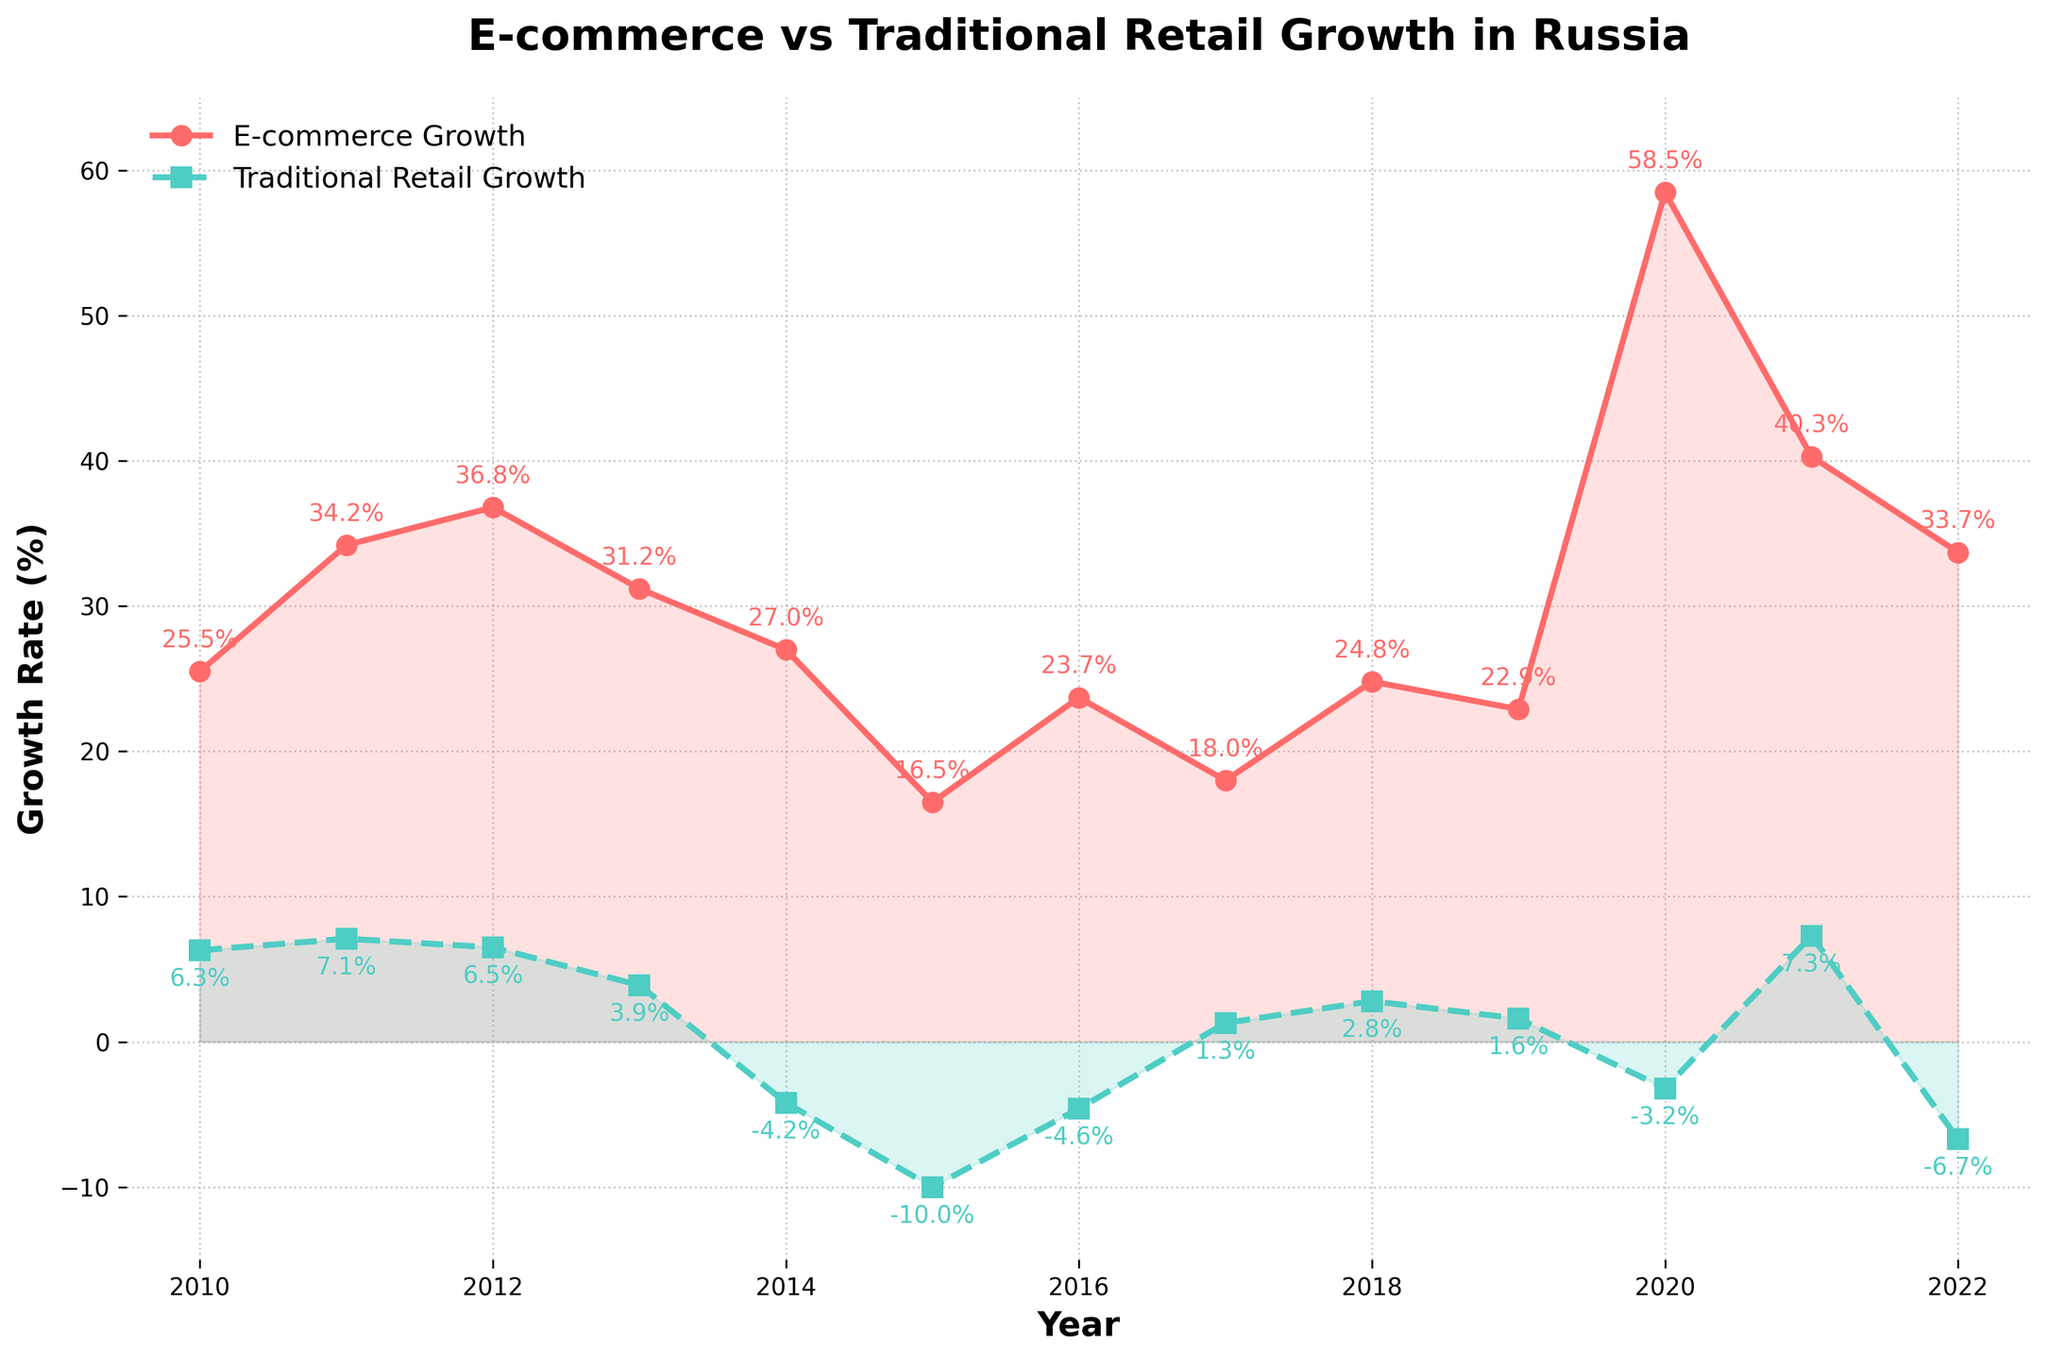What's the year with the highest growth in e-commerce? Identify the peak point in the line representing e-commerce growth. The highest point (58.5%) occurs in 2020.
Answer: 2020 Which year has the biggest difference between e-commerce and traditional retail growth rates? Calculate the difference between e-commerce and traditional retail growth for each year. The year with the largest gap is 2020 with a difference of 61.7% (58.5% - (-3.2%)).
Answer: 2020 During which years did e-commerce growth exceed 30%? Look at the points on the e-commerce line that are above the 30% mark. The years where e-commerce growth exceeded 30% are 2011, 2012, 2013, 2014, 2020, 2021, and 2022.
Answer: 2011, 2012, 2013, 2014, 2020, 2021, 2022 How many years did traditional retail experience negative growth? Count the years where the traditional retail line is below 0 on the y-axis. Negative growth years for traditional retail are 2014, 2015, 2016, 2020, and 2022.
Answer: 5 years In which year did e-commerce growth see the largest increase compared to the previous year? Subtract the e-commerce growth values of each year from its previous year to find the largest increase. The largest increase is between 2019 and 2020 (58.5% - 22.9% = 35.6%).
Answer: 2020 When was the traditional retail growth rate the lowest? Identify the lowest point on the traditional retail line. The lowest growth rate for traditional retail is -10.0% in 2015.
Answer: 2015 Which year had both e-commerce and traditional retail growth rates positive? Check for overlapping years where both lines are above the 0% mark. Only in 2011, 2012, 2013, 2017, 2018, and 2021 both e-commerce and traditional retail growth rates are positive.
Answer: 2011, 2012, 2013, 2017, 2018, 2021 What's the average growth rate of traditional retail over the years 2010-2022? Sum the traditional retail growth rates for each year, then divide by the number of years (13). (-33.3 / 13 = -2.56%).
Answer: -2.56% In which years did traditional retail experience a positive growth spike after a negative growth year? Identify years where the traditional retail line moves from negative to positive. This happened in 2017 (previously -4.6%) and 2021 (previously -3.2%).
Answer: 2017 and 2021 How does the 2022 growth rate for traditional retail compare to 2010? Look at the traditional retail growth rates for both 2010 and 2022. The 2022 rate (-6.7%) is lower than the 2010 rate (6.3%).
Answer: Lower 